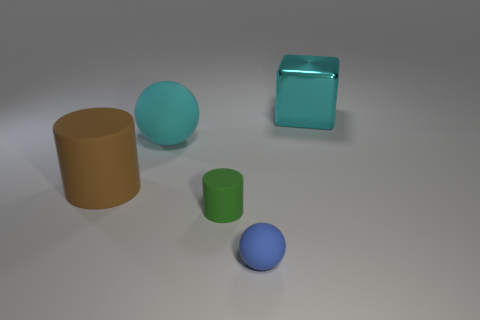Subtract all blocks. How many objects are left? 4 Subtract 2 cylinders. How many cylinders are left? 0 Subtract all brown blocks. How many purple cylinders are left? 0 Subtract all cyan rubber spheres. Subtract all small green metallic cylinders. How many objects are left? 4 Add 1 cyan matte objects. How many cyan matte objects are left? 2 Add 3 small brown objects. How many small brown objects exist? 3 Add 2 small blue things. How many objects exist? 7 Subtract all green cylinders. How many cylinders are left? 1 Subtract 0 purple cylinders. How many objects are left? 5 Subtract all gray spheres. Subtract all purple cylinders. How many spheres are left? 2 